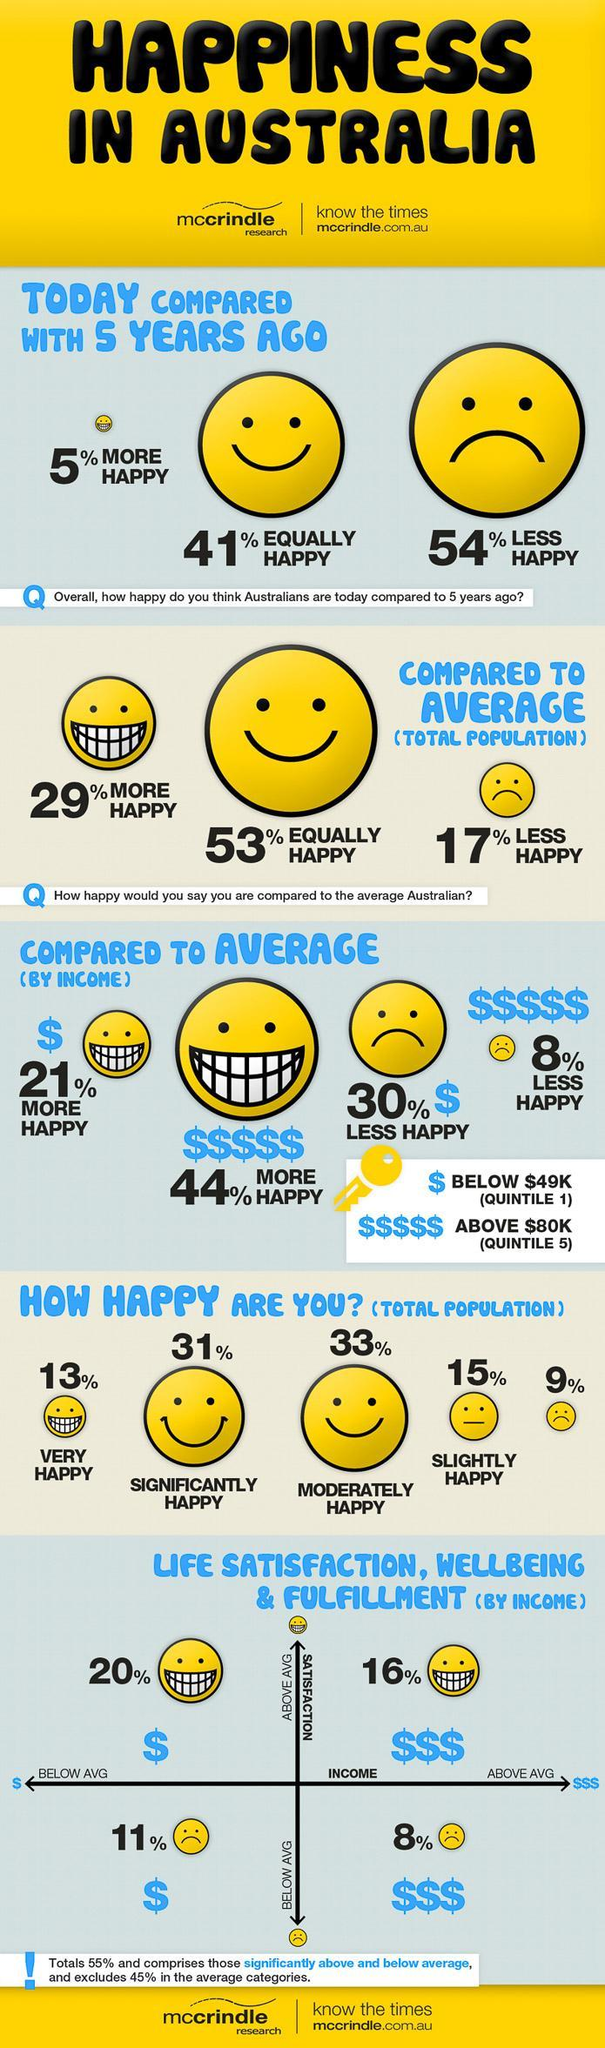What percentage of the population is " slightly happy "?
Answer the question with a short phrase. 15% What percentage of the population is " moderately happy "? 33% 